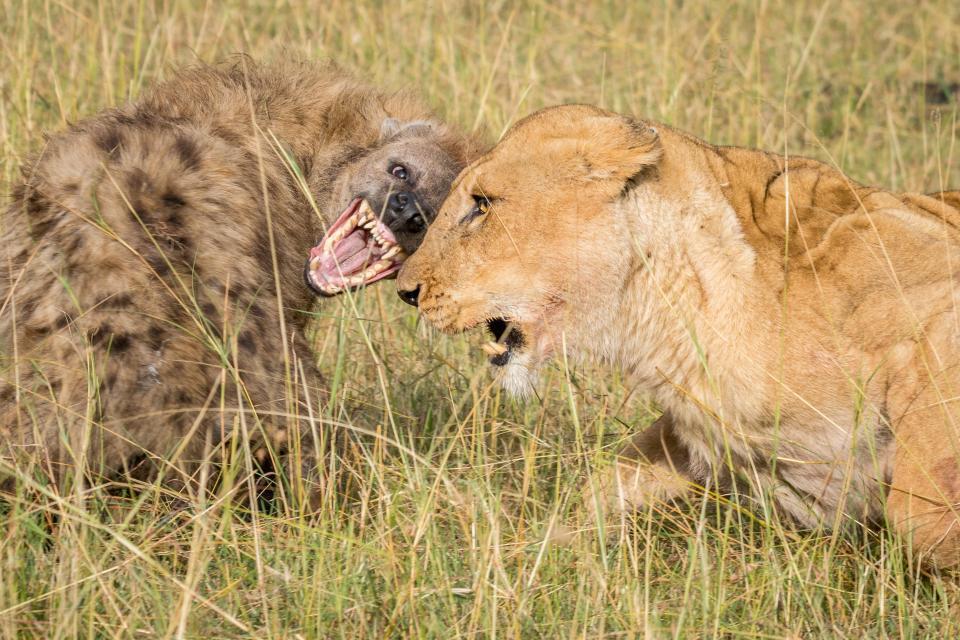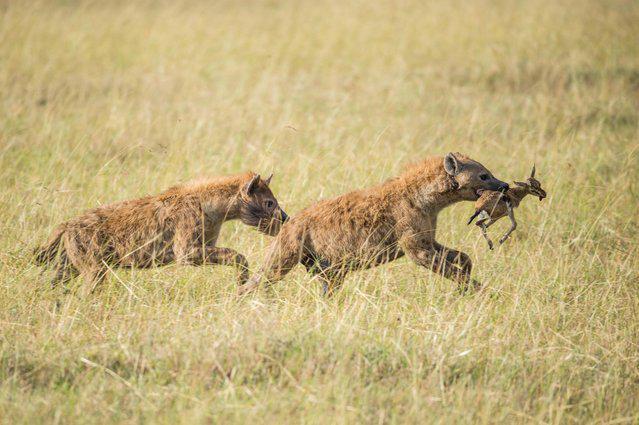The first image is the image on the left, the second image is the image on the right. For the images shown, is this caption "There are at most 4 hyenas." true? Answer yes or no. Yes. The first image is the image on the left, the second image is the image on the right. Evaluate the accuracy of this statement regarding the images: "The image on the left has one hyena that is facing towards the right.". Is it true? Answer yes or no. No. 